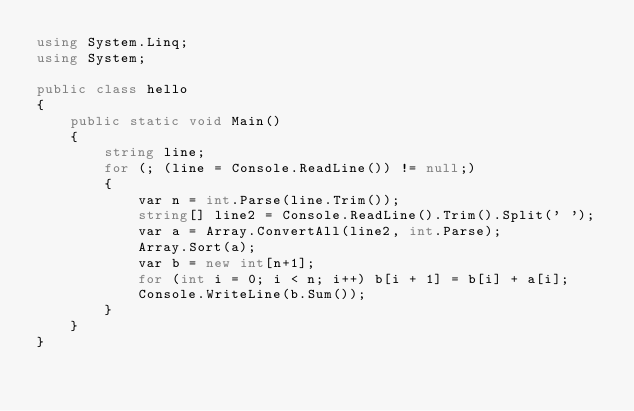<code> <loc_0><loc_0><loc_500><loc_500><_C#_>using System.Linq;
using System;

public class hello
{
    public static void Main()
    {
        string line;
        for (; (line = Console.ReadLine()) != null;)
        {
            var n = int.Parse(line.Trim());
            string[] line2 = Console.ReadLine().Trim().Split(' ');
            var a = Array.ConvertAll(line2, int.Parse);
            Array.Sort(a);
            var b = new int[n+1];
            for (int i = 0; i < n; i++) b[i + 1] = b[i] + a[i];
            Console.WriteLine(b.Sum());
        }
    }
}</code> 